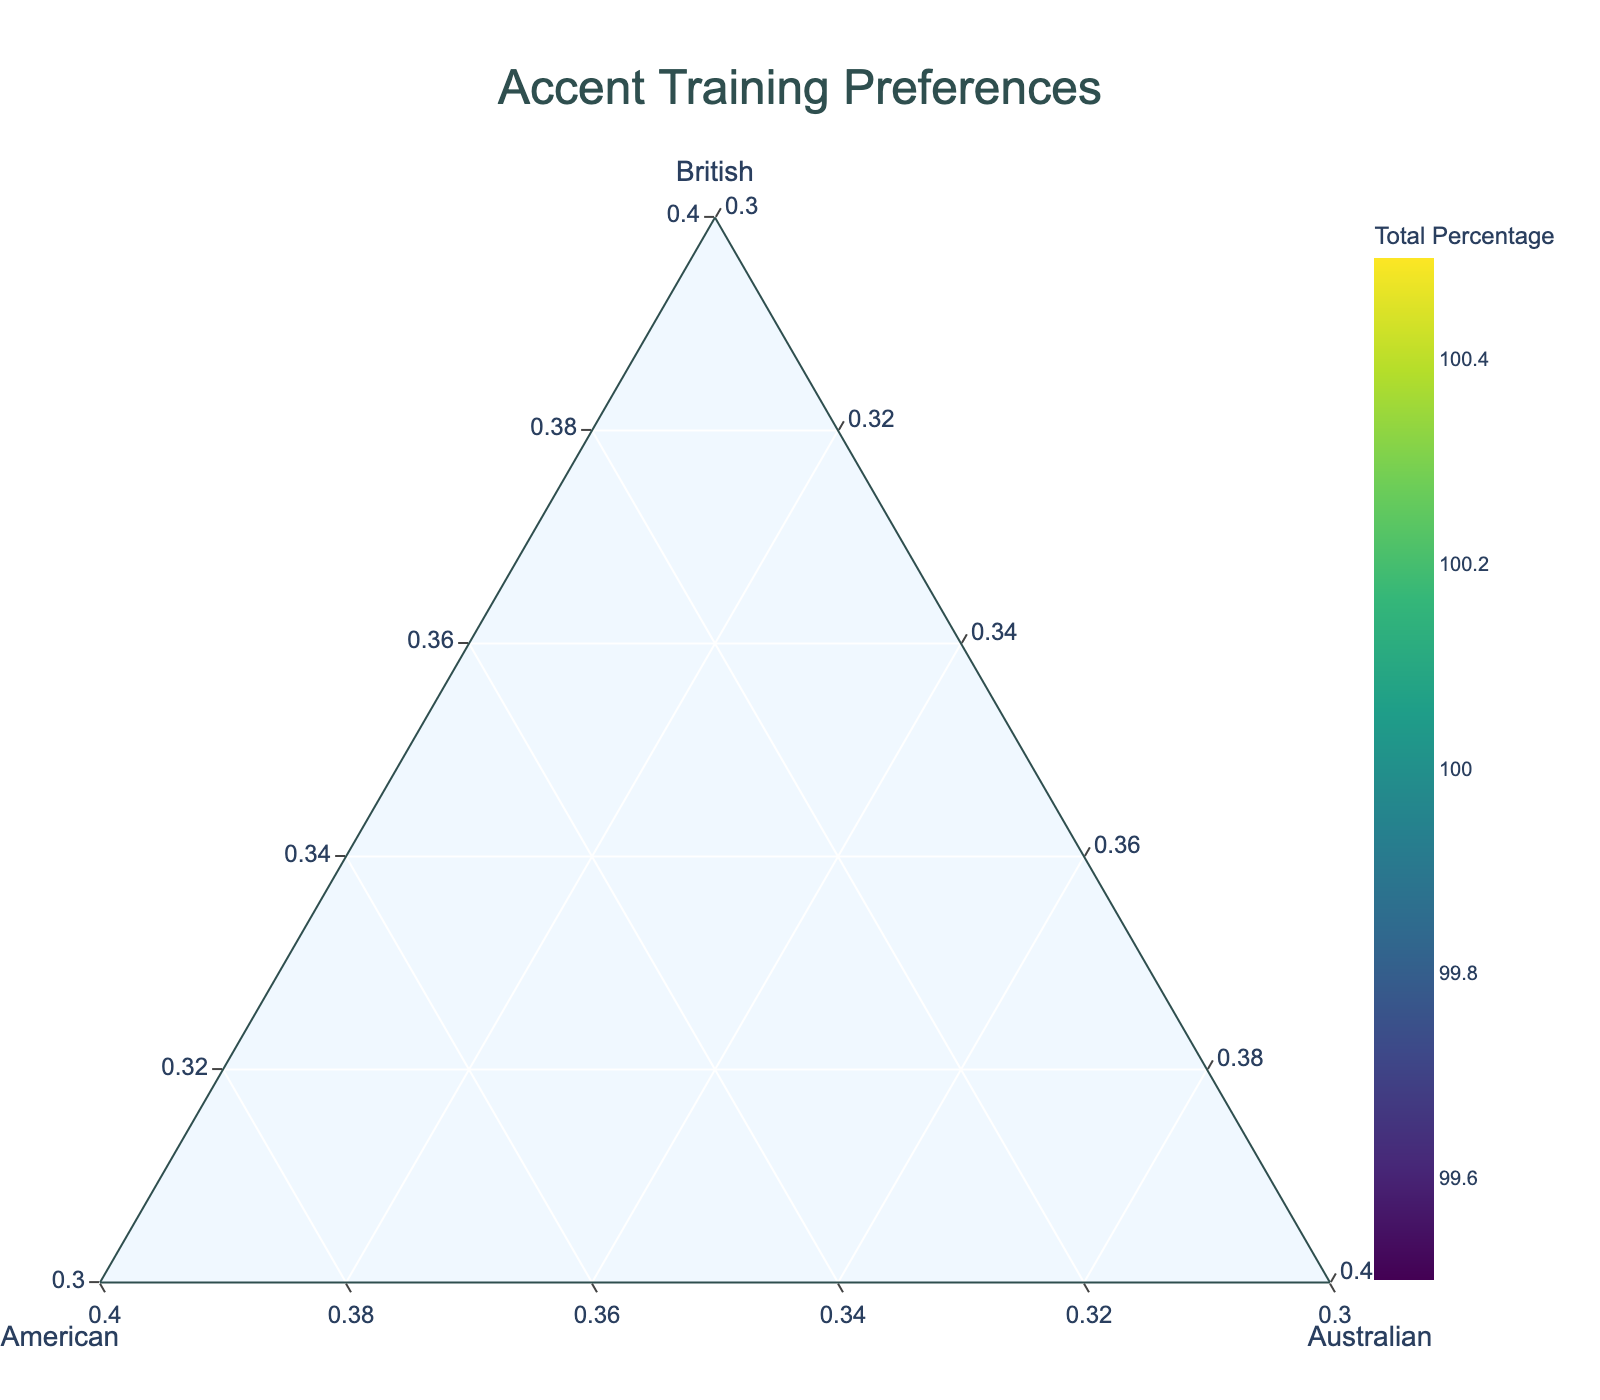What is the title of the figure? The title is usually located at the top center of the figure. From the provided layout, it can be clearly seen as "Accent Training Preferences".
Answer: Accent Training Preferences How many clients have preferences for British accent training above 65%? Check the locations in the ternary plot where the British axis percentage is above 65%. The clients are Emma Thompson, John Smith, Michael Brown, Oliver Taylor, and Amelia Wright.
Answer: 5 Which client has the highest percentage preference for the American accent? Find the data point that is closest to the American axis (B-axis). From the provided data, James Cooper has the highest percentage preference for the American accent with 70%.
Answer: James Cooper What is the sum of the percentages for a client with 55% British, 35% American, and 10% Australian accent training? Add the percentages for British (55%), American (35%), and Australian (10%), which totals 100%.
Answer: 100% Which axis has a minimum value of 30%? Each of the axes (British, American, Australian) has a minimum value of 30% as specified in the ternary plot layout.
Answer: British, American, Australian Who prefers accent training with 45% British, 45% American, and 10% Australian? Locate on the ternary plot where the British and American percentages are each around 45%, with the Australian percentage at 10%. The client matching this criterion is Lucy Parker.
Answer: Lucy Parker What is the average percentage preference for the Australian accent across all clients? Add the percentages for Australian accent training for all clients and divide by the number of clients. The sum is 10 + 5 + 10 + 10 + 10 + 5 + 10 + 10 + 10 + 10 + 5 + 10 + 15 + 15 + 10 = 145. Dividing this by 15 clients gives approximately 9.67%.
Answer: 9.67% Which data point has the smallest overall point size in the plot? The point size represents the total percentage, which is always 100%. Since all data points have the same total percentage, they will all have equal sizes.
Answer: All equal 